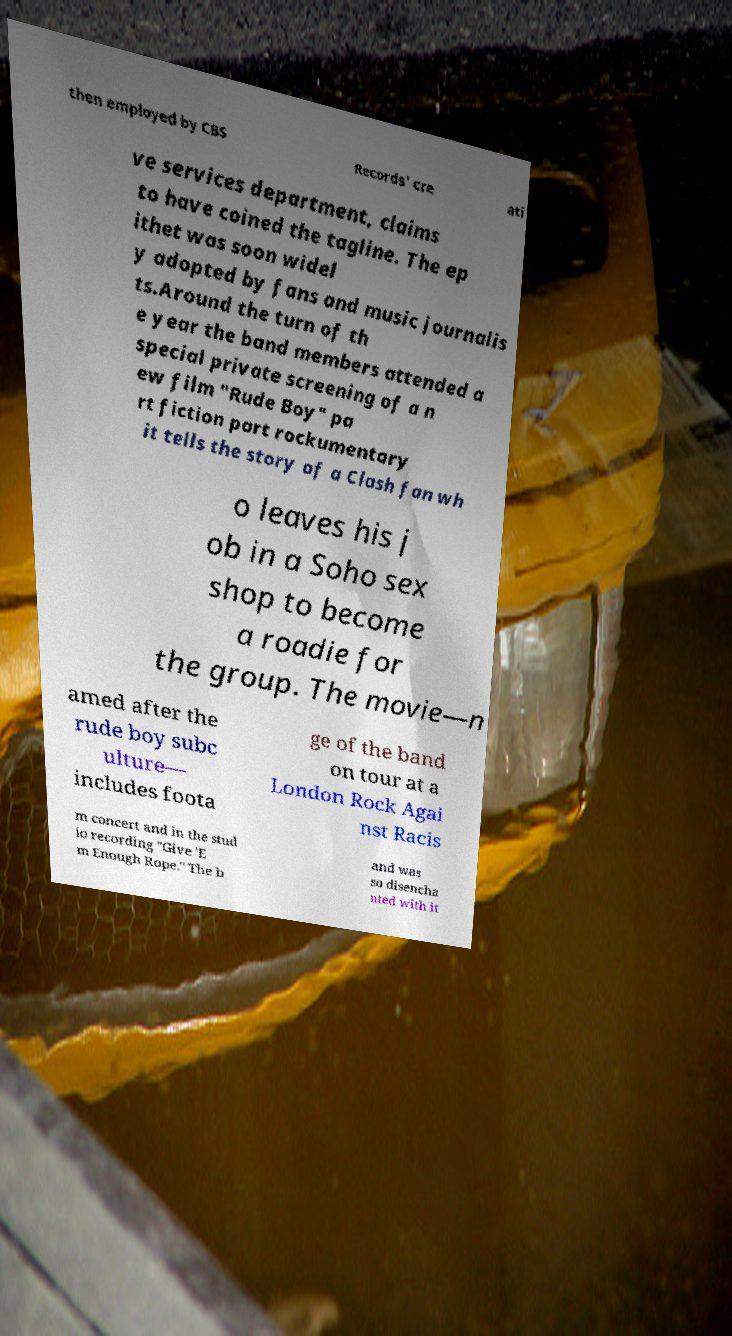I need the written content from this picture converted into text. Can you do that? then employed by CBS Records' cre ati ve services department, claims to have coined the tagline. The ep ithet was soon widel y adopted by fans and music journalis ts.Around the turn of th e year the band members attended a special private screening of a n ew film "Rude Boy" pa rt fiction part rockumentary it tells the story of a Clash fan wh o leaves his j ob in a Soho sex shop to become a roadie for the group. The movie—n amed after the rude boy subc ulture— includes foota ge of the band on tour at a London Rock Agai nst Racis m concert and in the stud io recording "Give 'E m Enough Rope." The b and was so disencha nted with it 